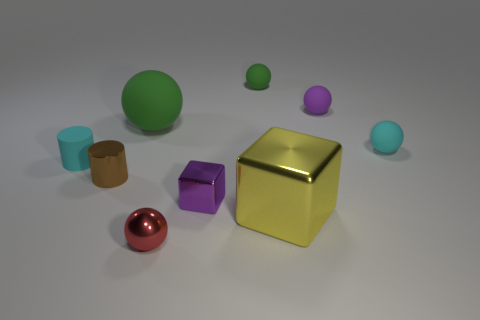Is the number of tiny brown cylinders that are to the right of the big metal object the same as the number of tiny purple blocks that are in front of the small rubber cylinder?
Your answer should be very brief. No. What material is the big green thing?
Give a very brief answer. Rubber. What is the big object that is behind the small rubber cylinder made of?
Give a very brief answer. Rubber. Is the number of cyan cylinders that are behind the small brown shiny cylinder greater than the number of brown metallic spheres?
Offer a very short reply. Yes. There is a cyan object that is left of the matte sphere left of the small red metallic sphere; are there any tiny things behind it?
Provide a short and direct response. Yes. Are there any small green matte objects on the right side of the large ball?
Provide a succinct answer. Yes. What number of tiny cubes have the same color as the matte cylinder?
Ensure brevity in your answer.  0. What is the size of the yellow object that is made of the same material as the red thing?
Provide a succinct answer. Large. What is the size of the green matte sphere that is to the left of the purple object in front of the cyan thing that is on the left side of the tiny block?
Your response must be concise. Large. There is a green sphere on the left side of the small green matte object; what is its size?
Provide a short and direct response. Large. 